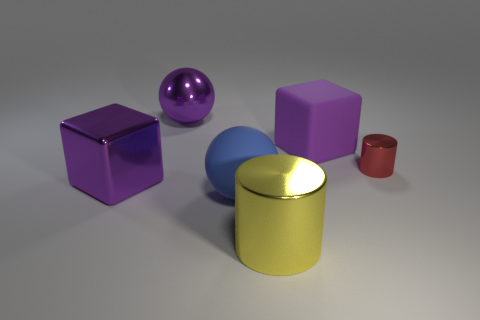Subtract 1 balls. How many balls are left? 1 Subtract all yellow cylinders. How many cylinders are left? 1 Add 5 large cubes. How many large cubes exist? 7 Add 2 balls. How many objects exist? 8 Subtract 0 brown cubes. How many objects are left? 6 Subtract all blue spheres. Subtract all blue cylinders. How many spheres are left? 1 Subtract all purple cylinders. How many green cubes are left? 0 Subtract all large metallic blocks. Subtract all big shiny things. How many objects are left? 2 Add 2 purple metallic objects. How many purple metallic objects are left? 4 